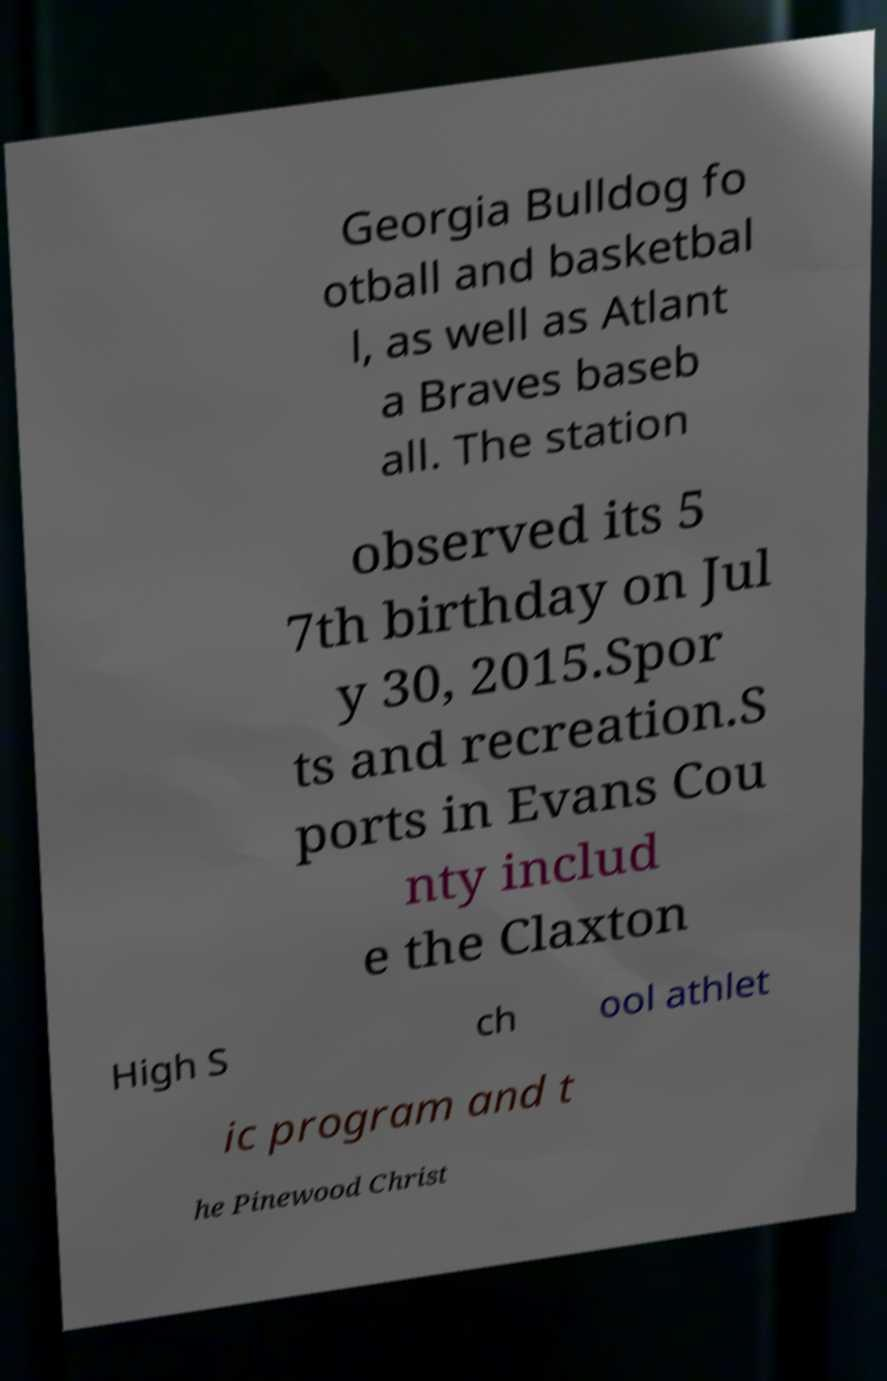For documentation purposes, I need the text within this image transcribed. Could you provide that? Georgia Bulldog fo otball and basketbal l, as well as Atlant a Braves baseb all. The station observed its 5 7th birthday on Jul y 30, 2015.Spor ts and recreation.S ports in Evans Cou nty includ e the Claxton High S ch ool athlet ic program and t he Pinewood Christ 